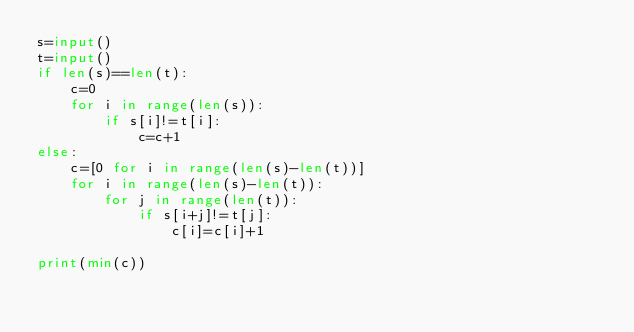<code> <loc_0><loc_0><loc_500><loc_500><_Python_>s=input()
t=input()
if len(s)==len(t):
    c=0
    for i in range(len(s)):
        if s[i]!=t[i]:
            c=c+1
else:
    c=[0 for i in range(len(s)-len(t))]
    for i in range(len(s)-len(t)):
        for j in range(len(t)):
            if s[i+j]!=t[j]:
                c[i]=c[i]+1

print(min(c))
</code> 